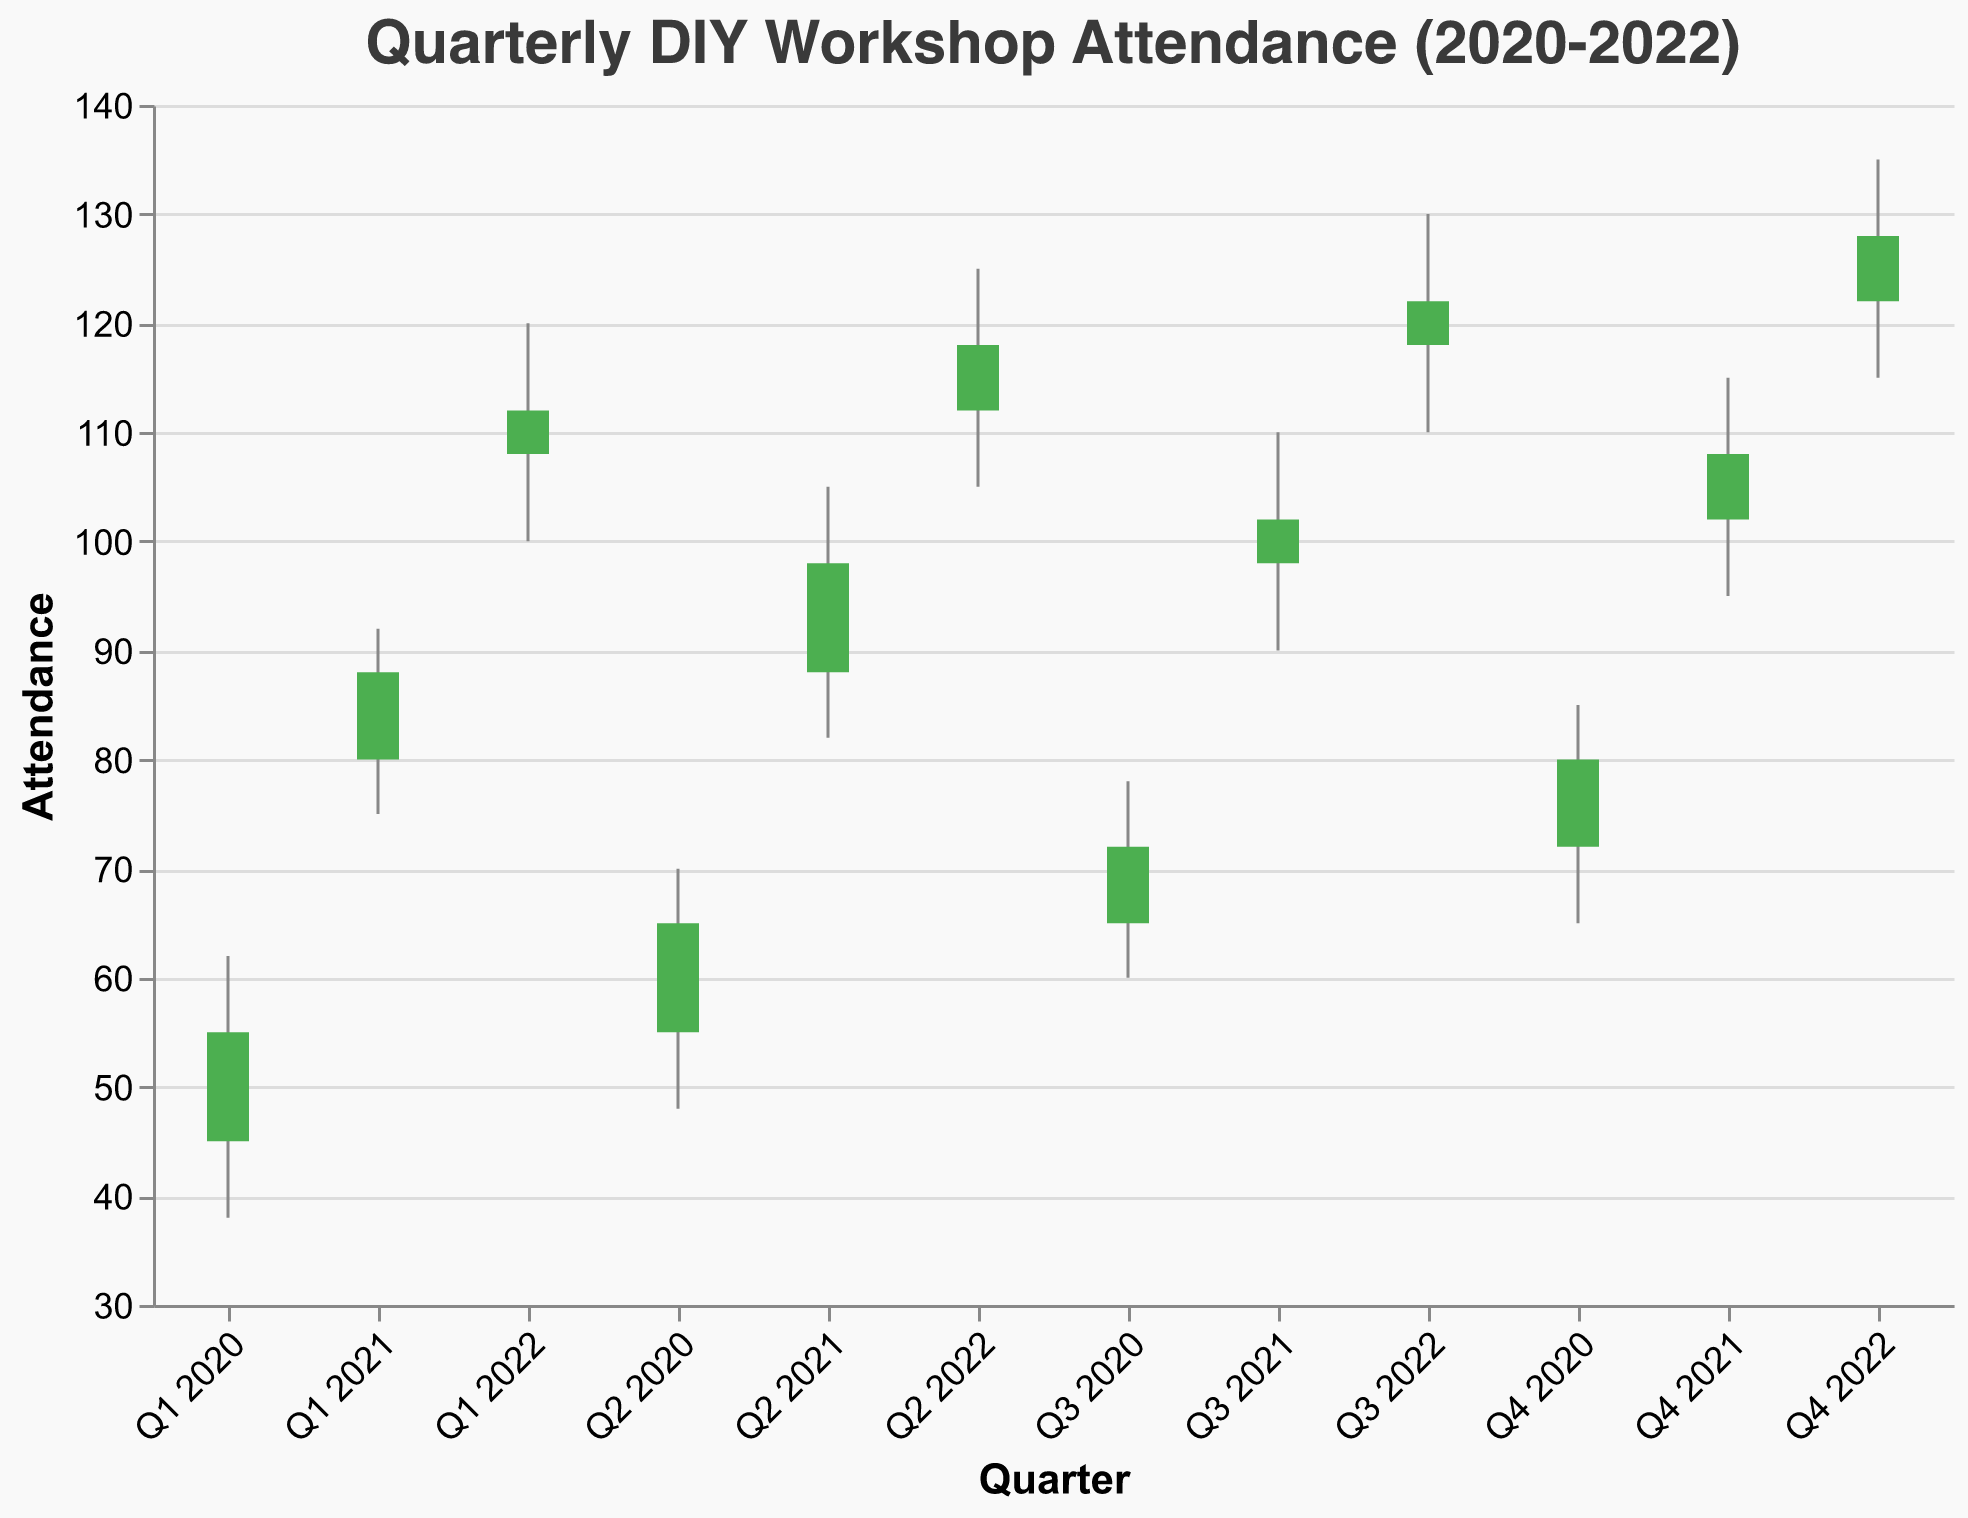Which quarter had the highest attendance in the data set? The quarter with the highest attendance is Q4 2022, with a 'Close' value of 128, which is the highest among all quarters.
Answer: Q4 2022 When was the largest single-quarter increase in attendance observed? The largest single-quarter increase is observed from Q1 2021 to Q2 2021. The 'Close' value increased from 88 in Q1 2021 to 98 in Q2 2021, a difference of 10.
Answer: Q1 2021 to Q2 2021 Which quarter had the least amount of variability in attendance? Variability can be assessed by the range between the 'High' and 'Low' values. Q2 2020 had the smallest range with 'High' at 70 and 'Low' at 48, a range of 22.
Answer: Q2 2020 What was the attendance trend in 2021? The overall trend for 2021 shows a consistent increase in attendance. The 'Open' values go from 80 in Q1 2021 to 102 in Q4 2021, and the 'Close' values increase from 88 in Q1 2021 to 108 in Q4 2021.
Answer: Increasing How does the attendance in Q3 2020 compare to Q3 2022? In Q3 2020, the 'Close' value was 72, whereas in Q3 2022, it was 122. This shows that attendance in Q3 2022 was significantly higher than in Q3 2020.
Answer: Q3 2022 had higher attendance Is there any quarter where the closing attendance was lower than the opening attendance? No, in every quarter, the 'Close' value is higher than the 'Open' value, indicating an increase in attendance by the end of each quarter.
Answer: No 